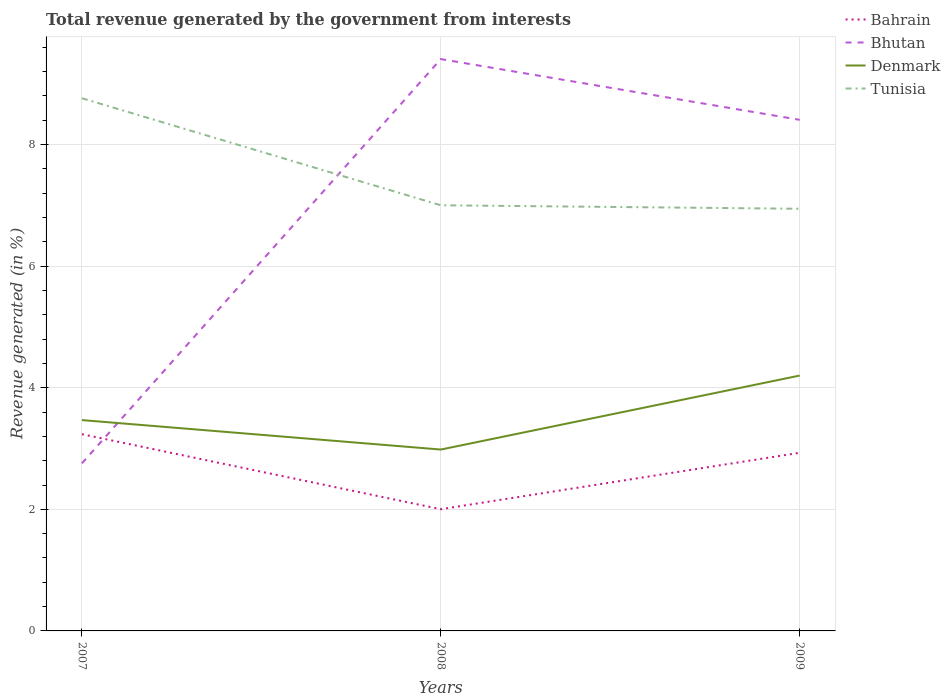Does the line corresponding to Tunisia intersect with the line corresponding to Bahrain?
Keep it short and to the point. No. Is the number of lines equal to the number of legend labels?
Give a very brief answer. Yes. Across all years, what is the maximum total revenue generated in Tunisia?
Your response must be concise. 6.94. In which year was the total revenue generated in Denmark maximum?
Give a very brief answer. 2008. What is the total total revenue generated in Bhutan in the graph?
Offer a very short reply. 1. What is the difference between the highest and the second highest total revenue generated in Bhutan?
Give a very brief answer. 6.65. Are the values on the major ticks of Y-axis written in scientific E-notation?
Your answer should be very brief. No. Does the graph contain any zero values?
Offer a terse response. No. Does the graph contain grids?
Your answer should be compact. Yes. What is the title of the graph?
Provide a short and direct response. Total revenue generated by the government from interests. Does "Brazil" appear as one of the legend labels in the graph?
Provide a succinct answer. No. What is the label or title of the X-axis?
Your answer should be very brief. Years. What is the label or title of the Y-axis?
Ensure brevity in your answer.  Revenue generated (in %). What is the Revenue generated (in %) of Bahrain in 2007?
Give a very brief answer. 3.24. What is the Revenue generated (in %) in Bhutan in 2007?
Ensure brevity in your answer.  2.76. What is the Revenue generated (in %) in Denmark in 2007?
Make the answer very short. 3.47. What is the Revenue generated (in %) in Tunisia in 2007?
Your answer should be compact. 8.76. What is the Revenue generated (in %) in Bahrain in 2008?
Give a very brief answer. 2. What is the Revenue generated (in %) in Bhutan in 2008?
Make the answer very short. 9.41. What is the Revenue generated (in %) of Denmark in 2008?
Offer a very short reply. 2.98. What is the Revenue generated (in %) in Tunisia in 2008?
Ensure brevity in your answer.  7. What is the Revenue generated (in %) of Bahrain in 2009?
Provide a succinct answer. 2.93. What is the Revenue generated (in %) in Bhutan in 2009?
Offer a very short reply. 8.41. What is the Revenue generated (in %) in Denmark in 2009?
Offer a very short reply. 4.2. What is the Revenue generated (in %) in Tunisia in 2009?
Make the answer very short. 6.94. Across all years, what is the maximum Revenue generated (in %) in Bahrain?
Provide a succinct answer. 3.24. Across all years, what is the maximum Revenue generated (in %) of Bhutan?
Your response must be concise. 9.41. Across all years, what is the maximum Revenue generated (in %) of Denmark?
Provide a short and direct response. 4.2. Across all years, what is the maximum Revenue generated (in %) of Tunisia?
Provide a succinct answer. 8.76. Across all years, what is the minimum Revenue generated (in %) in Bahrain?
Your response must be concise. 2. Across all years, what is the minimum Revenue generated (in %) in Bhutan?
Your answer should be compact. 2.76. Across all years, what is the minimum Revenue generated (in %) of Denmark?
Keep it short and to the point. 2.98. Across all years, what is the minimum Revenue generated (in %) in Tunisia?
Your answer should be compact. 6.94. What is the total Revenue generated (in %) of Bahrain in the graph?
Offer a very short reply. 8.17. What is the total Revenue generated (in %) of Bhutan in the graph?
Ensure brevity in your answer.  20.57. What is the total Revenue generated (in %) in Denmark in the graph?
Offer a very short reply. 10.65. What is the total Revenue generated (in %) of Tunisia in the graph?
Provide a short and direct response. 22.71. What is the difference between the Revenue generated (in %) of Bahrain in 2007 and that in 2008?
Make the answer very short. 1.23. What is the difference between the Revenue generated (in %) of Bhutan in 2007 and that in 2008?
Your answer should be compact. -6.65. What is the difference between the Revenue generated (in %) in Denmark in 2007 and that in 2008?
Make the answer very short. 0.48. What is the difference between the Revenue generated (in %) of Tunisia in 2007 and that in 2008?
Your response must be concise. 1.76. What is the difference between the Revenue generated (in %) in Bahrain in 2007 and that in 2009?
Your response must be concise. 0.31. What is the difference between the Revenue generated (in %) in Bhutan in 2007 and that in 2009?
Ensure brevity in your answer.  -5.65. What is the difference between the Revenue generated (in %) of Denmark in 2007 and that in 2009?
Make the answer very short. -0.73. What is the difference between the Revenue generated (in %) of Tunisia in 2007 and that in 2009?
Provide a short and direct response. 1.82. What is the difference between the Revenue generated (in %) in Bahrain in 2008 and that in 2009?
Your response must be concise. -0.93. What is the difference between the Revenue generated (in %) in Denmark in 2008 and that in 2009?
Make the answer very short. -1.22. What is the difference between the Revenue generated (in %) of Tunisia in 2008 and that in 2009?
Your response must be concise. 0.06. What is the difference between the Revenue generated (in %) in Bahrain in 2007 and the Revenue generated (in %) in Bhutan in 2008?
Make the answer very short. -6.17. What is the difference between the Revenue generated (in %) of Bahrain in 2007 and the Revenue generated (in %) of Denmark in 2008?
Your response must be concise. 0.25. What is the difference between the Revenue generated (in %) of Bahrain in 2007 and the Revenue generated (in %) of Tunisia in 2008?
Your answer should be compact. -3.77. What is the difference between the Revenue generated (in %) of Bhutan in 2007 and the Revenue generated (in %) of Denmark in 2008?
Ensure brevity in your answer.  -0.23. What is the difference between the Revenue generated (in %) of Bhutan in 2007 and the Revenue generated (in %) of Tunisia in 2008?
Keep it short and to the point. -4.25. What is the difference between the Revenue generated (in %) of Denmark in 2007 and the Revenue generated (in %) of Tunisia in 2008?
Offer a very short reply. -3.53. What is the difference between the Revenue generated (in %) in Bahrain in 2007 and the Revenue generated (in %) in Bhutan in 2009?
Your answer should be very brief. -5.17. What is the difference between the Revenue generated (in %) in Bahrain in 2007 and the Revenue generated (in %) in Denmark in 2009?
Provide a succinct answer. -0.96. What is the difference between the Revenue generated (in %) of Bahrain in 2007 and the Revenue generated (in %) of Tunisia in 2009?
Keep it short and to the point. -3.71. What is the difference between the Revenue generated (in %) in Bhutan in 2007 and the Revenue generated (in %) in Denmark in 2009?
Keep it short and to the point. -1.44. What is the difference between the Revenue generated (in %) of Bhutan in 2007 and the Revenue generated (in %) of Tunisia in 2009?
Make the answer very short. -4.19. What is the difference between the Revenue generated (in %) in Denmark in 2007 and the Revenue generated (in %) in Tunisia in 2009?
Your answer should be compact. -3.48. What is the difference between the Revenue generated (in %) in Bahrain in 2008 and the Revenue generated (in %) in Bhutan in 2009?
Make the answer very short. -6.4. What is the difference between the Revenue generated (in %) of Bahrain in 2008 and the Revenue generated (in %) of Denmark in 2009?
Your answer should be compact. -2.2. What is the difference between the Revenue generated (in %) of Bahrain in 2008 and the Revenue generated (in %) of Tunisia in 2009?
Your answer should be very brief. -4.94. What is the difference between the Revenue generated (in %) in Bhutan in 2008 and the Revenue generated (in %) in Denmark in 2009?
Make the answer very short. 5.21. What is the difference between the Revenue generated (in %) of Bhutan in 2008 and the Revenue generated (in %) of Tunisia in 2009?
Offer a terse response. 2.46. What is the difference between the Revenue generated (in %) in Denmark in 2008 and the Revenue generated (in %) in Tunisia in 2009?
Provide a succinct answer. -3.96. What is the average Revenue generated (in %) of Bahrain per year?
Your answer should be very brief. 2.72. What is the average Revenue generated (in %) in Bhutan per year?
Keep it short and to the point. 6.86. What is the average Revenue generated (in %) of Denmark per year?
Offer a very short reply. 3.55. What is the average Revenue generated (in %) of Tunisia per year?
Make the answer very short. 7.57. In the year 2007, what is the difference between the Revenue generated (in %) of Bahrain and Revenue generated (in %) of Bhutan?
Offer a very short reply. 0.48. In the year 2007, what is the difference between the Revenue generated (in %) in Bahrain and Revenue generated (in %) in Denmark?
Keep it short and to the point. -0.23. In the year 2007, what is the difference between the Revenue generated (in %) of Bahrain and Revenue generated (in %) of Tunisia?
Ensure brevity in your answer.  -5.53. In the year 2007, what is the difference between the Revenue generated (in %) of Bhutan and Revenue generated (in %) of Denmark?
Keep it short and to the point. -0.71. In the year 2007, what is the difference between the Revenue generated (in %) in Bhutan and Revenue generated (in %) in Tunisia?
Give a very brief answer. -6.01. In the year 2007, what is the difference between the Revenue generated (in %) of Denmark and Revenue generated (in %) of Tunisia?
Your answer should be very brief. -5.29. In the year 2008, what is the difference between the Revenue generated (in %) of Bahrain and Revenue generated (in %) of Bhutan?
Your answer should be very brief. -7.4. In the year 2008, what is the difference between the Revenue generated (in %) of Bahrain and Revenue generated (in %) of Denmark?
Ensure brevity in your answer.  -0.98. In the year 2008, what is the difference between the Revenue generated (in %) in Bahrain and Revenue generated (in %) in Tunisia?
Keep it short and to the point. -5. In the year 2008, what is the difference between the Revenue generated (in %) in Bhutan and Revenue generated (in %) in Denmark?
Your answer should be compact. 6.42. In the year 2008, what is the difference between the Revenue generated (in %) of Bhutan and Revenue generated (in %) of Tunisia?
Provide a succinct answer. 2.4. In the year 2008, what is the difference between the Revenue generated (in %) of Denmark and Revenue generated (in %) of Tunisia?
Offer a terse response. -4.02. In the year 2009, what is the difference between the Revenue generated (in %) in Bahrain and Revenue generated (in %) in Bhutan?
Make the answer very short. -5.48. In the year 2009, what is the difference between the Revenue generated (in %) of Bahrain and Revenue generated (in %) of Denmark?
Make the answer very short. -1.27. In the year 2009, what is the difference between the Revenue generated (in %) of Bahrain and Revenue generated (in %) of Tunisia?
Your response must be concise. -4.01. In the year 2009, what is the difference between the Revenue generated (in %) in Bhutan and Revenue generated (in %) in Denmark?
Keep it short and to the point. 4.21. In the year 2009, what is the difference between the Revenue generated (in %) of Bhutan and Revenue generated (in %) of Tunisia?
Your answer should be very brief. 1.46. In the year 2009, what is the difference between the Revenue generated (in %) in Denmark and Revenue generated (in %) in Tunisia?
Offer a very short reply. -2.74. What is the ratio of the Revenue generated (in %) of Bahrain in 2007 to that in 2008?
Give a very brief answer. 1.62. What is the ratio of the Revenue generated (in %) in Bhutan in 2007 to that in 2008?
Your answer should be very brief. 0.29. What is the ratio of the Revenue generated (in %) of Denmark in 2007 to that in 2008?
Give a very brief answer. 1.16. What is the ratio of the Revenue generated (in %) in Tunisia in 2007 to that in 2008?
Offer a very short reply. 1.25. What is the ratio of the Revenue generated (in %) of Bahrain in 2007 to that in 2009?
Keep it short and to the point. 1.1. What is the ratio of the Revenue generated (in %) of Bhutan in 2007 to that in 2009?
Your answer should be very brief. 0.33. What is the ratio of the Revenue generated (in %) in Denmark in 2007 to that in 2009?
Provide a succinct answer. 0.83. What is the ratio of the Revenue generated (in %) of Tunisia in 2007 to that in 2009?
Make the answer very short. 1.26. What is the ratio of the Revenue generated (in %) of Bahrain in 2008 to that in 2009?
Ensure brevity in your answer.  0.68. What is the ratio of the Revenue generated (in %) in Bhutan in 2008 to that in 2009?
Offer a terse response. 1.12. What is the ratio of the Revenue generated (in %) of Denmark in 2008 to that in 2009?
Your answer should be very brief. 0.71. What is the ratio of the Revenue generated (in %) of Tunisia in 2008 to that in 2009?
Ensure brevity in your answer.  1.01. What is the difference between the highest and the second highest Revenue generated (in %) in Bahrain?
Offer a terse response. 0.31. What is the difference between the highest and the second highest Revenue generated (in %) in Denmark?
Give a very brief answer. 0.73. What is the difference between the highest and the second highest Revenue generated (in %) of Tunisia?
Provide a succinct answer. 1.76. What is the difference between the highest and the lowest Revenue generated (in %) of Bahrain?
Provide a succinct answer. 1.23. What is the difference between the highest and the lowest Revenue generated (in %) of Bhutan?
Offer a terse response. 6.65. What is the difference between the highest and the lowest Revenue generated (in %) in Denmark?
Provide a short and direct response. 1.22. What is the difference between the highest and the lowest Revenue generated (in %) in Tunisia?
Your answer should be compact. 1.82. 